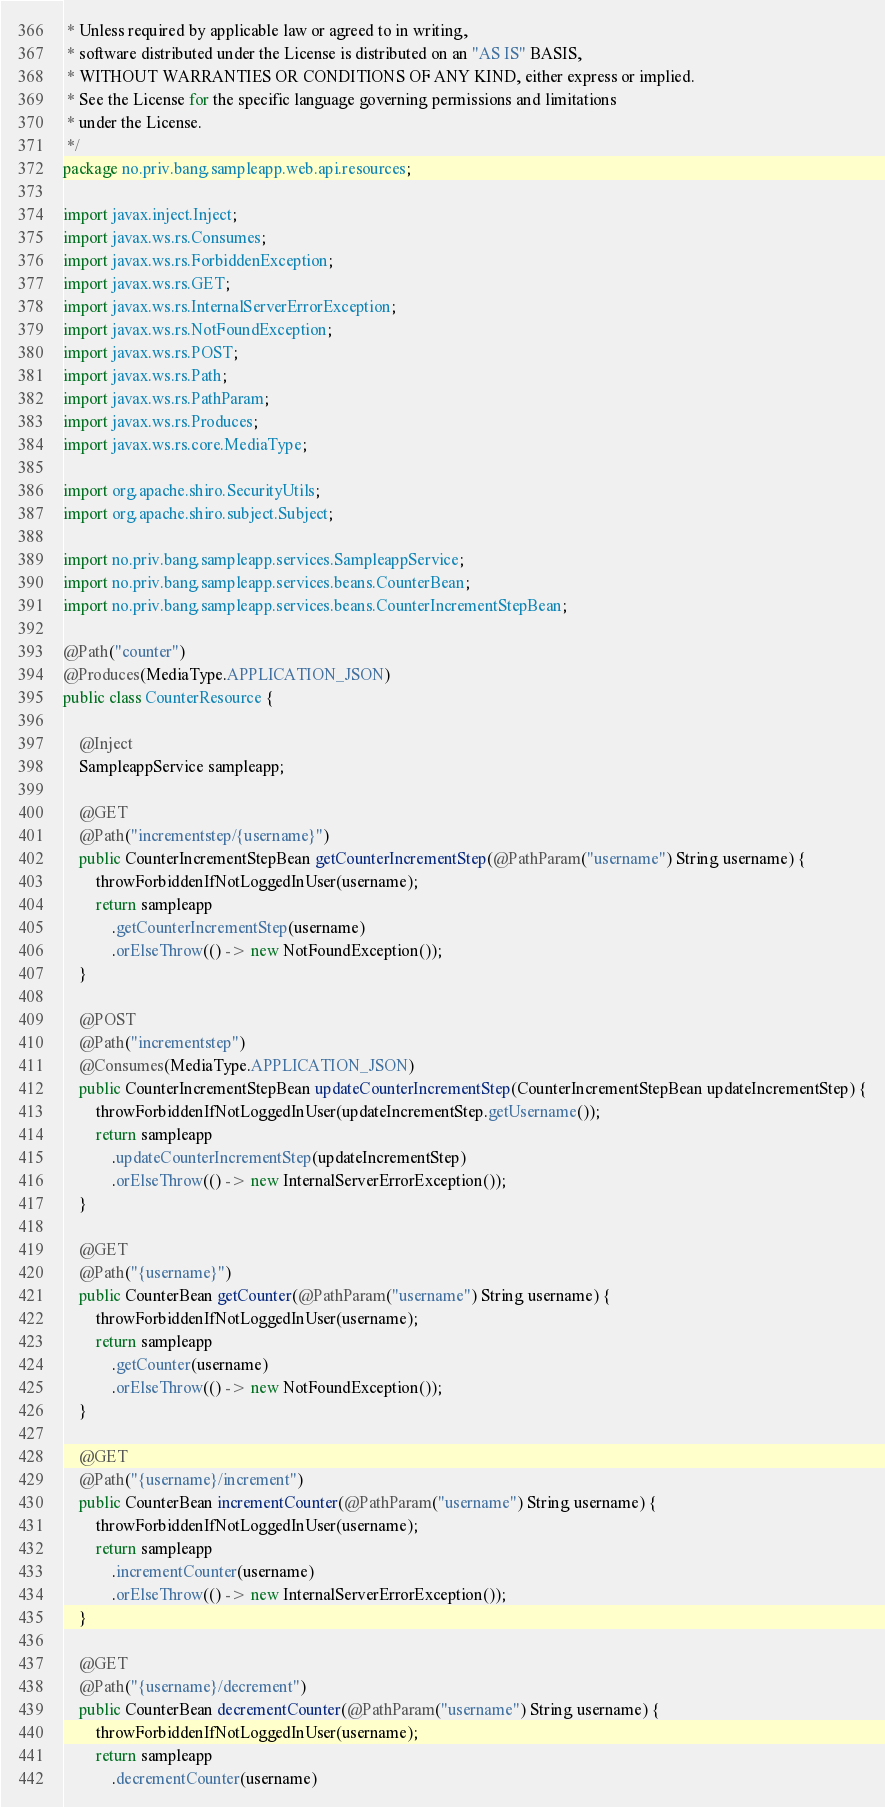<code> <loc_0><loc_0><loc_500><loc_500><_Java_> * Unless required by applicable law or agreed to in writing,
 * software distributed under the License is distributed on an "AS IS" BASIS,
 * WITHOUT WARRANTIES OR CONDITIONS OF ANY KIND, either express or implied.
 * See the License for the specific language governing permissions and limitations
 * under the License.
 */
package no.priv.bang.sampleapp.web.api.resources;

import javax.inject.Inject;
import javax.ws.rs.Consumes;
import javax.ws.rs.ForbiddenException;
import javax.ws.rs.GET;
import javax.ws.rs.InternalServerErrorException;
import javax.ws.rs.NotFoundException;
import javax.ws.rs.POST;
import javax.ws.rs.Path;
import javax.ws.rs.PathParam;
import javax.ws.rs.Produces;
import javax.ws.rs.core.MediaType;

import org.apache.shiro.SecurityUtils;
import org.apache.shiro.subject.Subject;

import no.priv.bang.sampleapp.services.SampleappService;
import no.priv.bang.sampleapp.services.beans.CounterBean;
import no.priv.bang.sampleapp.services.beans.CounterIncrementStepBean;

@Path("counter")
@Produces(MediaType.APPLICATION_JSON)
public class CounterResource {

    @Inject
    SampleappService sampleapp;

    @GET
    @Path("incrementstep/{username}")
    public CounterIncrementStepBean getCounterIncrementStep(@PathParam("username") String username) {
        throwForbiddenIfNotLoggedInUser(username);
        return sampleapp
            .getCounterIncrementStep(username)
            .orElseThrow(() -> new NotFoundException());
    }

    @POST
    @Path("incrementstep")
    @Consumes(MediaType.APPLICATION_JSON)
    public CounterIncrementStepBean updateCounterIncrementStep(CounterIncrementStepBean updateIncrementStep) {
        throwForbiddenIfNotLoggedInUser(updateIncrementStep.getUsername());
        return sampleapp
            .updateCounterIncrementStep(updateIncrementStep)
            .orElseThrow(() -> new InternalServerErrorException());
    }

    @GET
    @Path("{username}")
    public CounterBean getCounter(@PathParam("username") String username) {
        throwForbiddenIfNotLoggedInUser(username);
        return sampleapp
            .getCounter(username)
            .orElseThrow(() -> new NotFoundException());
    }

    @GET
    @Path("{username}/increment")
    public CounterBean incrementCounter(@PathParam("username") String username) {
        throwForbiddenIfNotLoggedInUser(username);
        return sampleapp
            .incrementCounter(username)
            .orElseThrow(() -> new InternalServerErrorException());
    }

    @GET
    @Path("{username}/decrement")
    public CounterBean decrementCounter(@PathParam("username") String username) {
        throwForbiddenIfNotLoggedInUser(username);
        return sampleapp
            .decrementCounter(username)</code> 